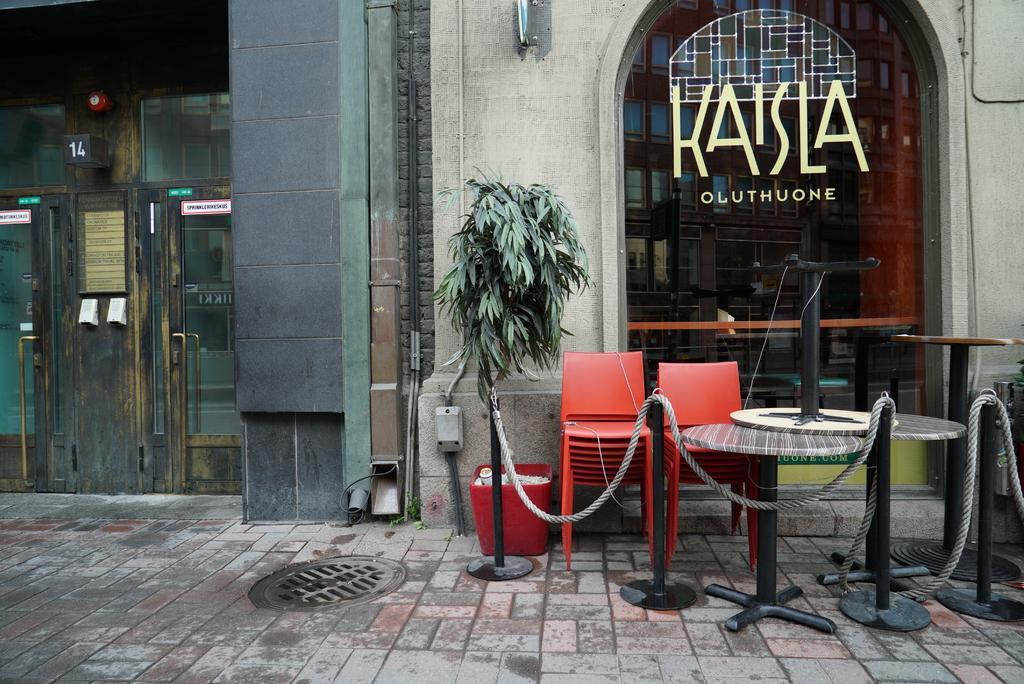In one or two sentences, can you explain what this image depicts? In this picture I can see the rope fence. I can see sitting chairs, tables on the right side. I can see the door on the left side. I can see the glass window on the right side. 